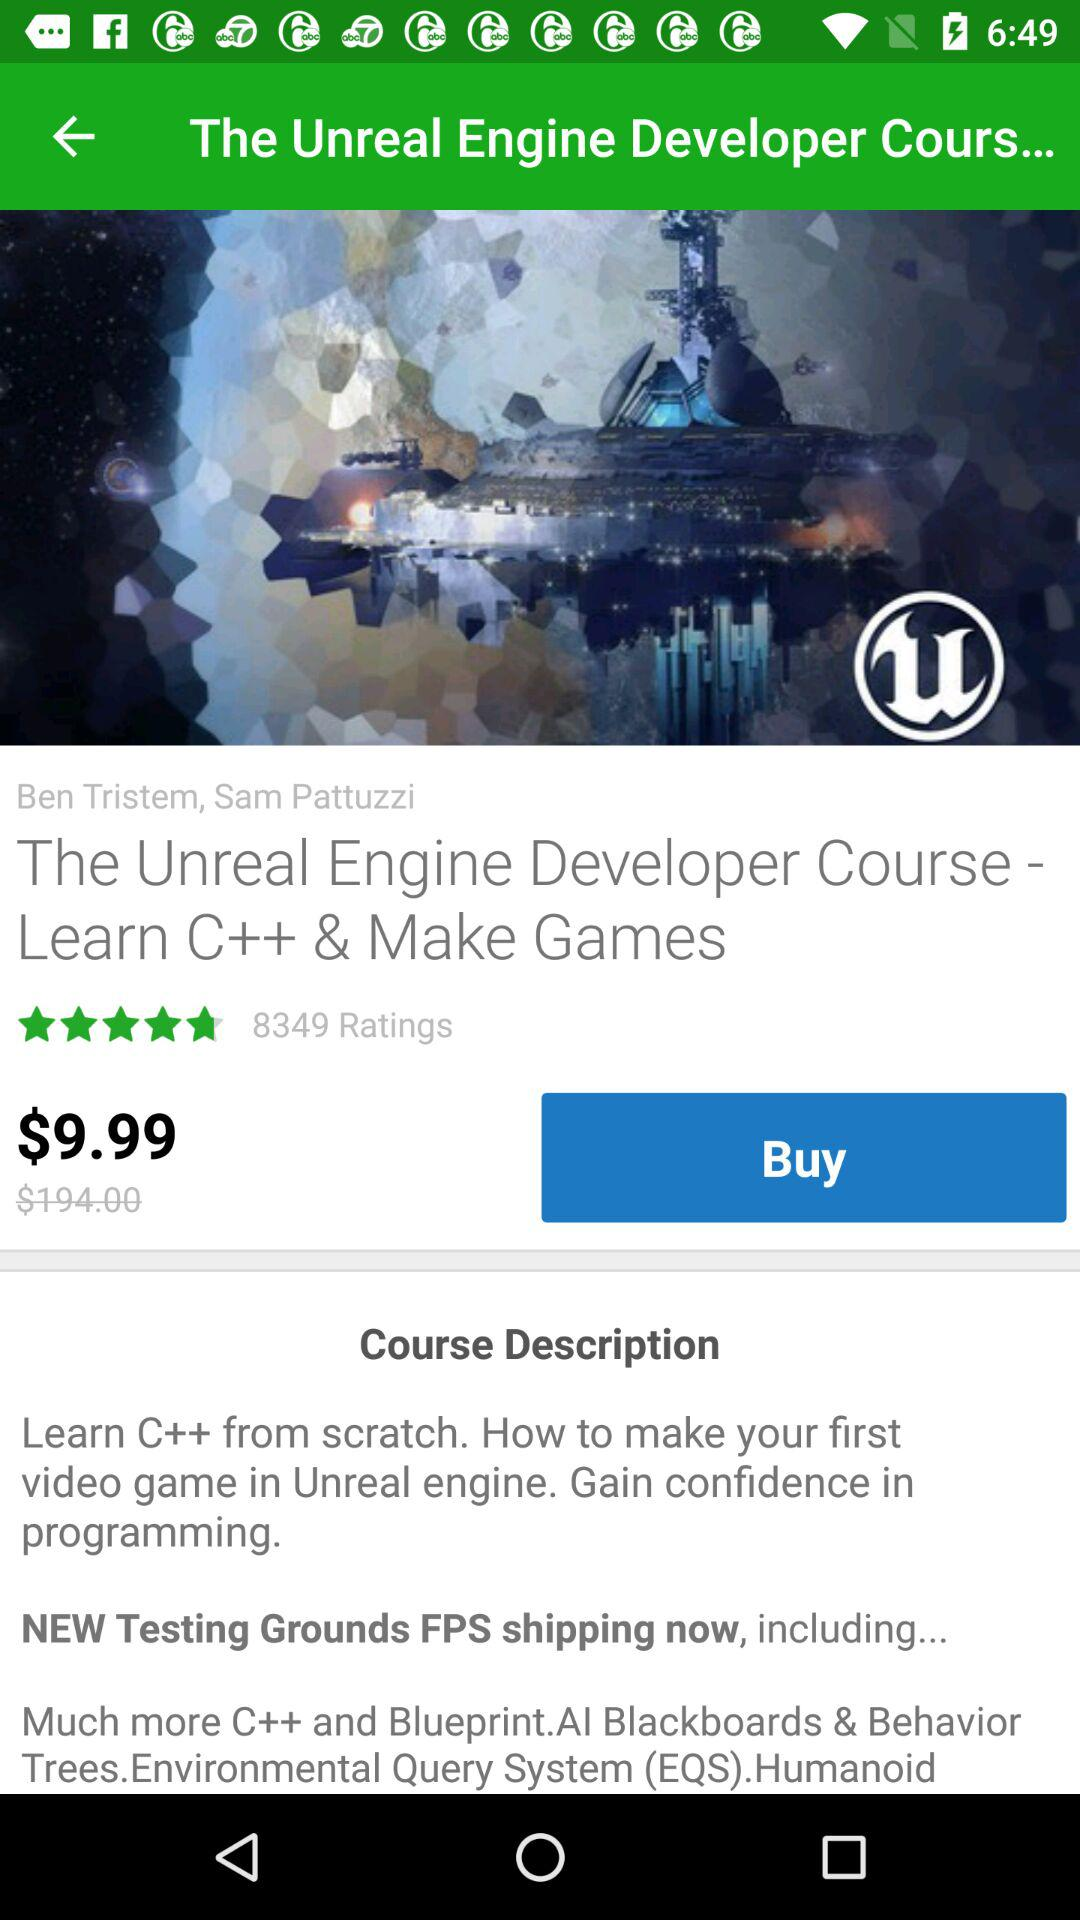What's the price before the offer? The price before the offer is $194.00. 